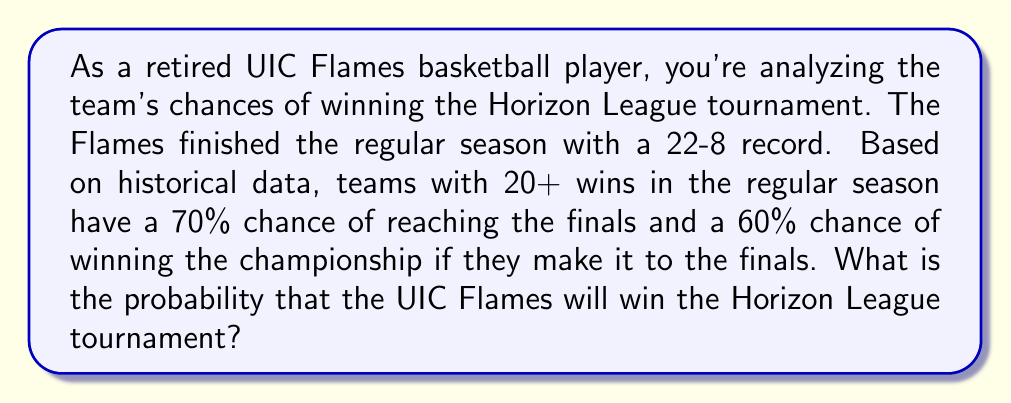Provide a solution to this math problem. Let's approach this step-by-step:

1) We need to consider two events:
   A: The team reaches the finals
   B: The team wins the championship (given they reach the finals)

2) We're given:
   P(A) = 0.70 (probability of reaching the finals)
   P(B|A) = 0.60 (probability of winning the championship given they reach the finals)

3) We want to find P(A ∩ B), which is the probability of both reaching the finals and winning the championship.

4) We can use the multiplication rule of probability:

   $$P(A ∩ B) = P(A) \cdot P(B|A)$$

5) Substituting the values:

   $$P(A ∩ B) = 0.70 \cdot 0.60 = 0.42$$

6) Therefore, the probability of the UIC Flames winning the Horizon League tournament is 0.42 or 42%.
Answer: 0.42 or 42% 